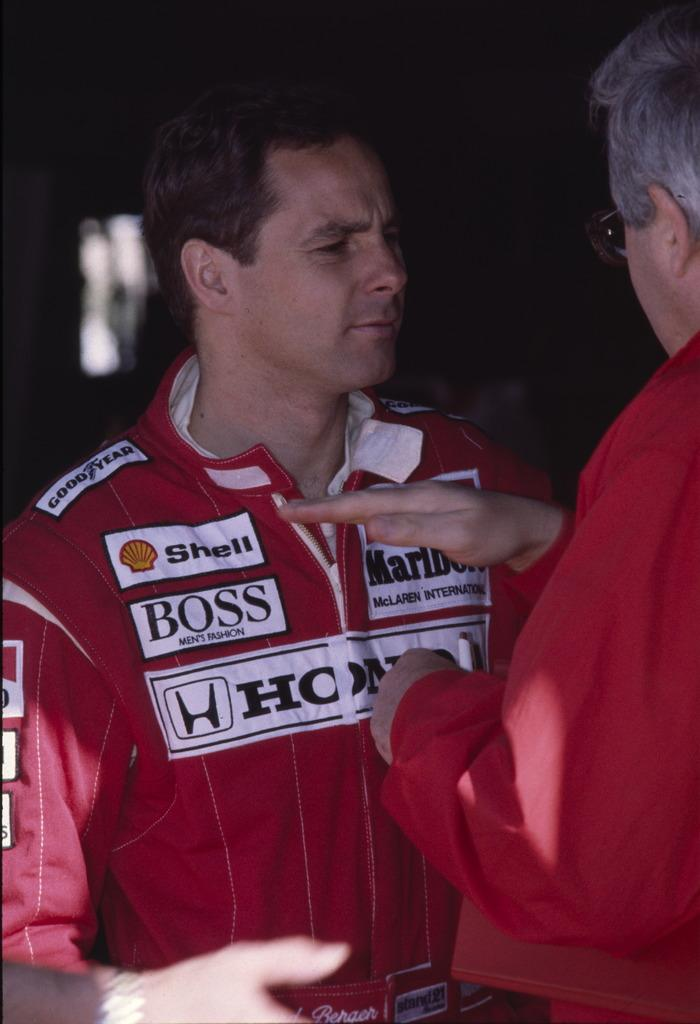<image>
Offer a succinct explanation of the picture presented. a men wearing patches by shell, boss, marlboro and honda 